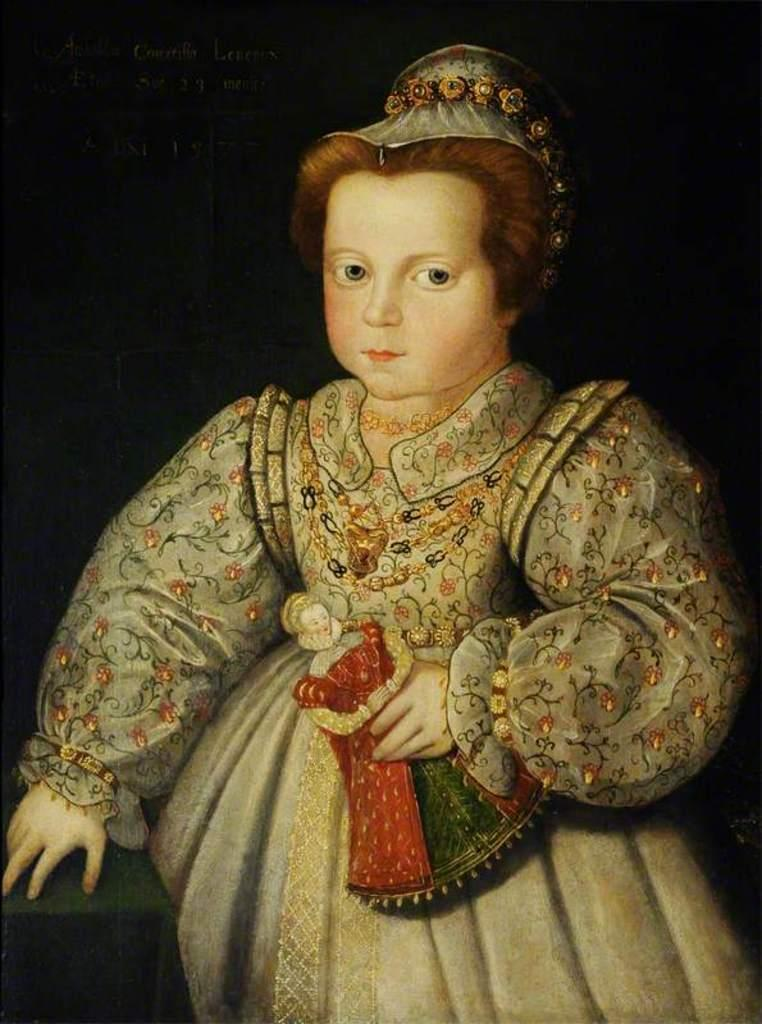Who is the main subject in the image? There is a girl in the image. What is the girl holding in the image? The girl is holding a doll. What type of image is this, and how is it created? The image appears to be a depiction or illustration, which suggests it is a drawing or painting. What can be observed about the background of the image? The background of the image is dark. What type of scarf is the girl wearing in the image? There is no scarf visible in the image; the girl is holding a doll. What is the condition of the doll in the image? The provided facts do not mention the condition of the doll, so we cannot determine its condition from the image. 